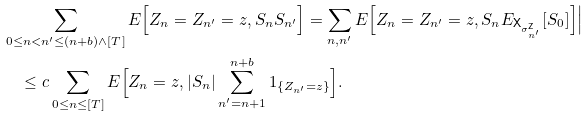<formula> <loc_0><loc_0><loc_500><loc_500>& \sum _ { 0 \leq n < n ^ { \prime } \leq ( n + b ) \wedge [ T ] } E \Big [ Z _ { n } = Z _ { n ^ { \prime } } = z , S _ { n } S _ { n ^ { \prime } } \Big ] = \sum _ { n , n ^ { \prime } } E \Big [ Z _ { n } = Z _ { n ^ { \prime } } = z , S _ { n } E _ { { \mathsf X } _ { \sigma ^ { \mathsf Z } _ { n ^ { \prime } } } } [ S _ { 0 } ] \Big ] \Big | \\ & \quad \leq c \sum _ { 0 \leq n \leq [ T ] } E \Big [ Z _ { n } = z , | S _ { n } | \sum _ { n ^ { \prime } = n + 1 } ^ { n + b } 1 _ { \{ Z _ { n ^ { \prime } } = z \} } \Big ] .</formula> 